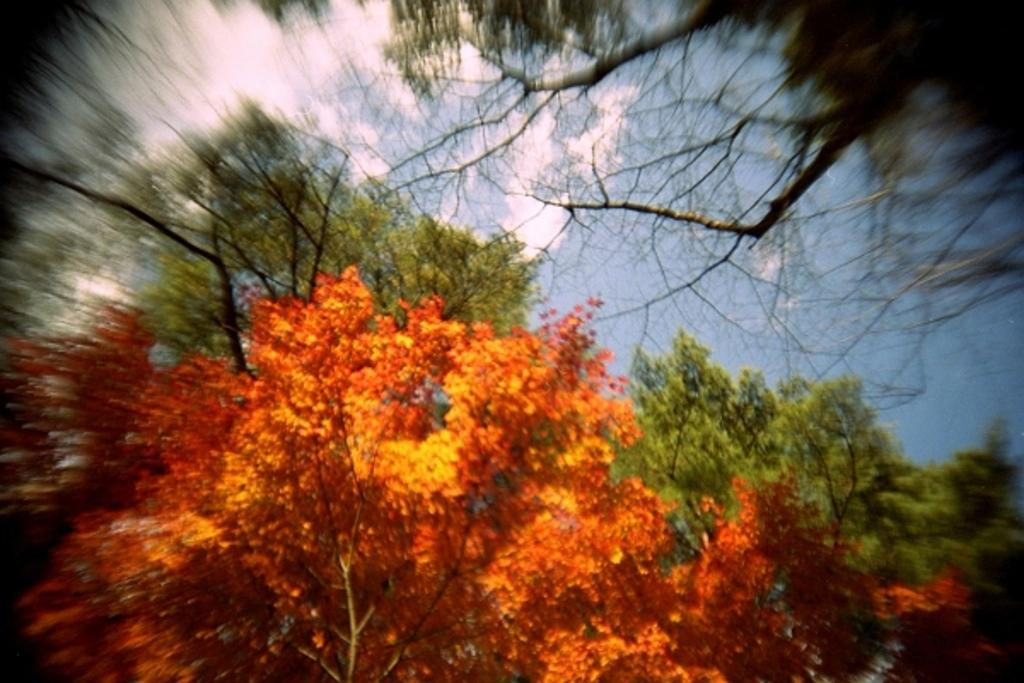What type of vegetation can be seen in the image? There are trees in the image. How are the edges of the image? The edges of the image are clear. What is the condition of the sky in the image? The sky is clear in the image. What is the weather like in the image? It is sunny in the image. How many bars of soap are visible in the image? There are no bars of soap present in the image. What type of property can be seen in the image? There is no property visible in the image; it features trees, a clear sky, and clear edges. 